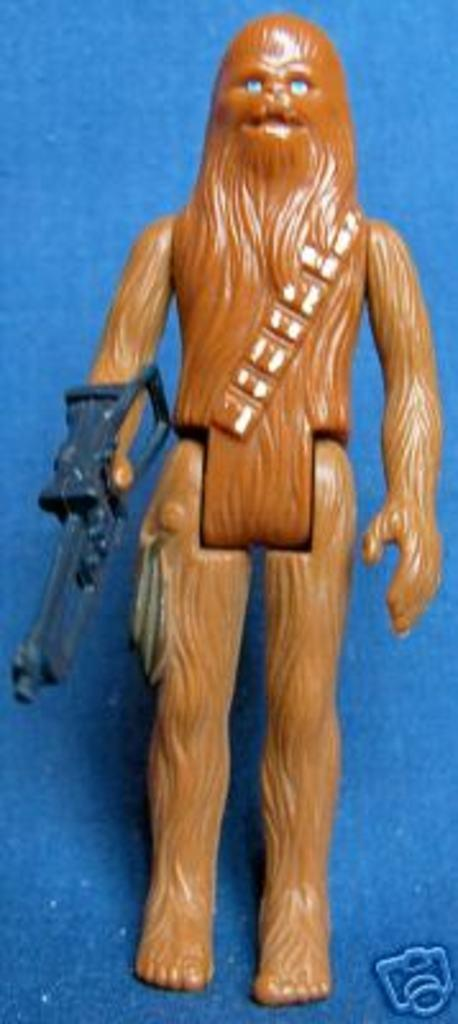What is placed on the surface in the image? There is a doll placed on a surface in the image. Can you describe any additional details about the image? There is a logo at the bottom of the image. What effect does the heat have on the doll in the image? There is no heat present in the image, so it cannot have any effect on the doll. 